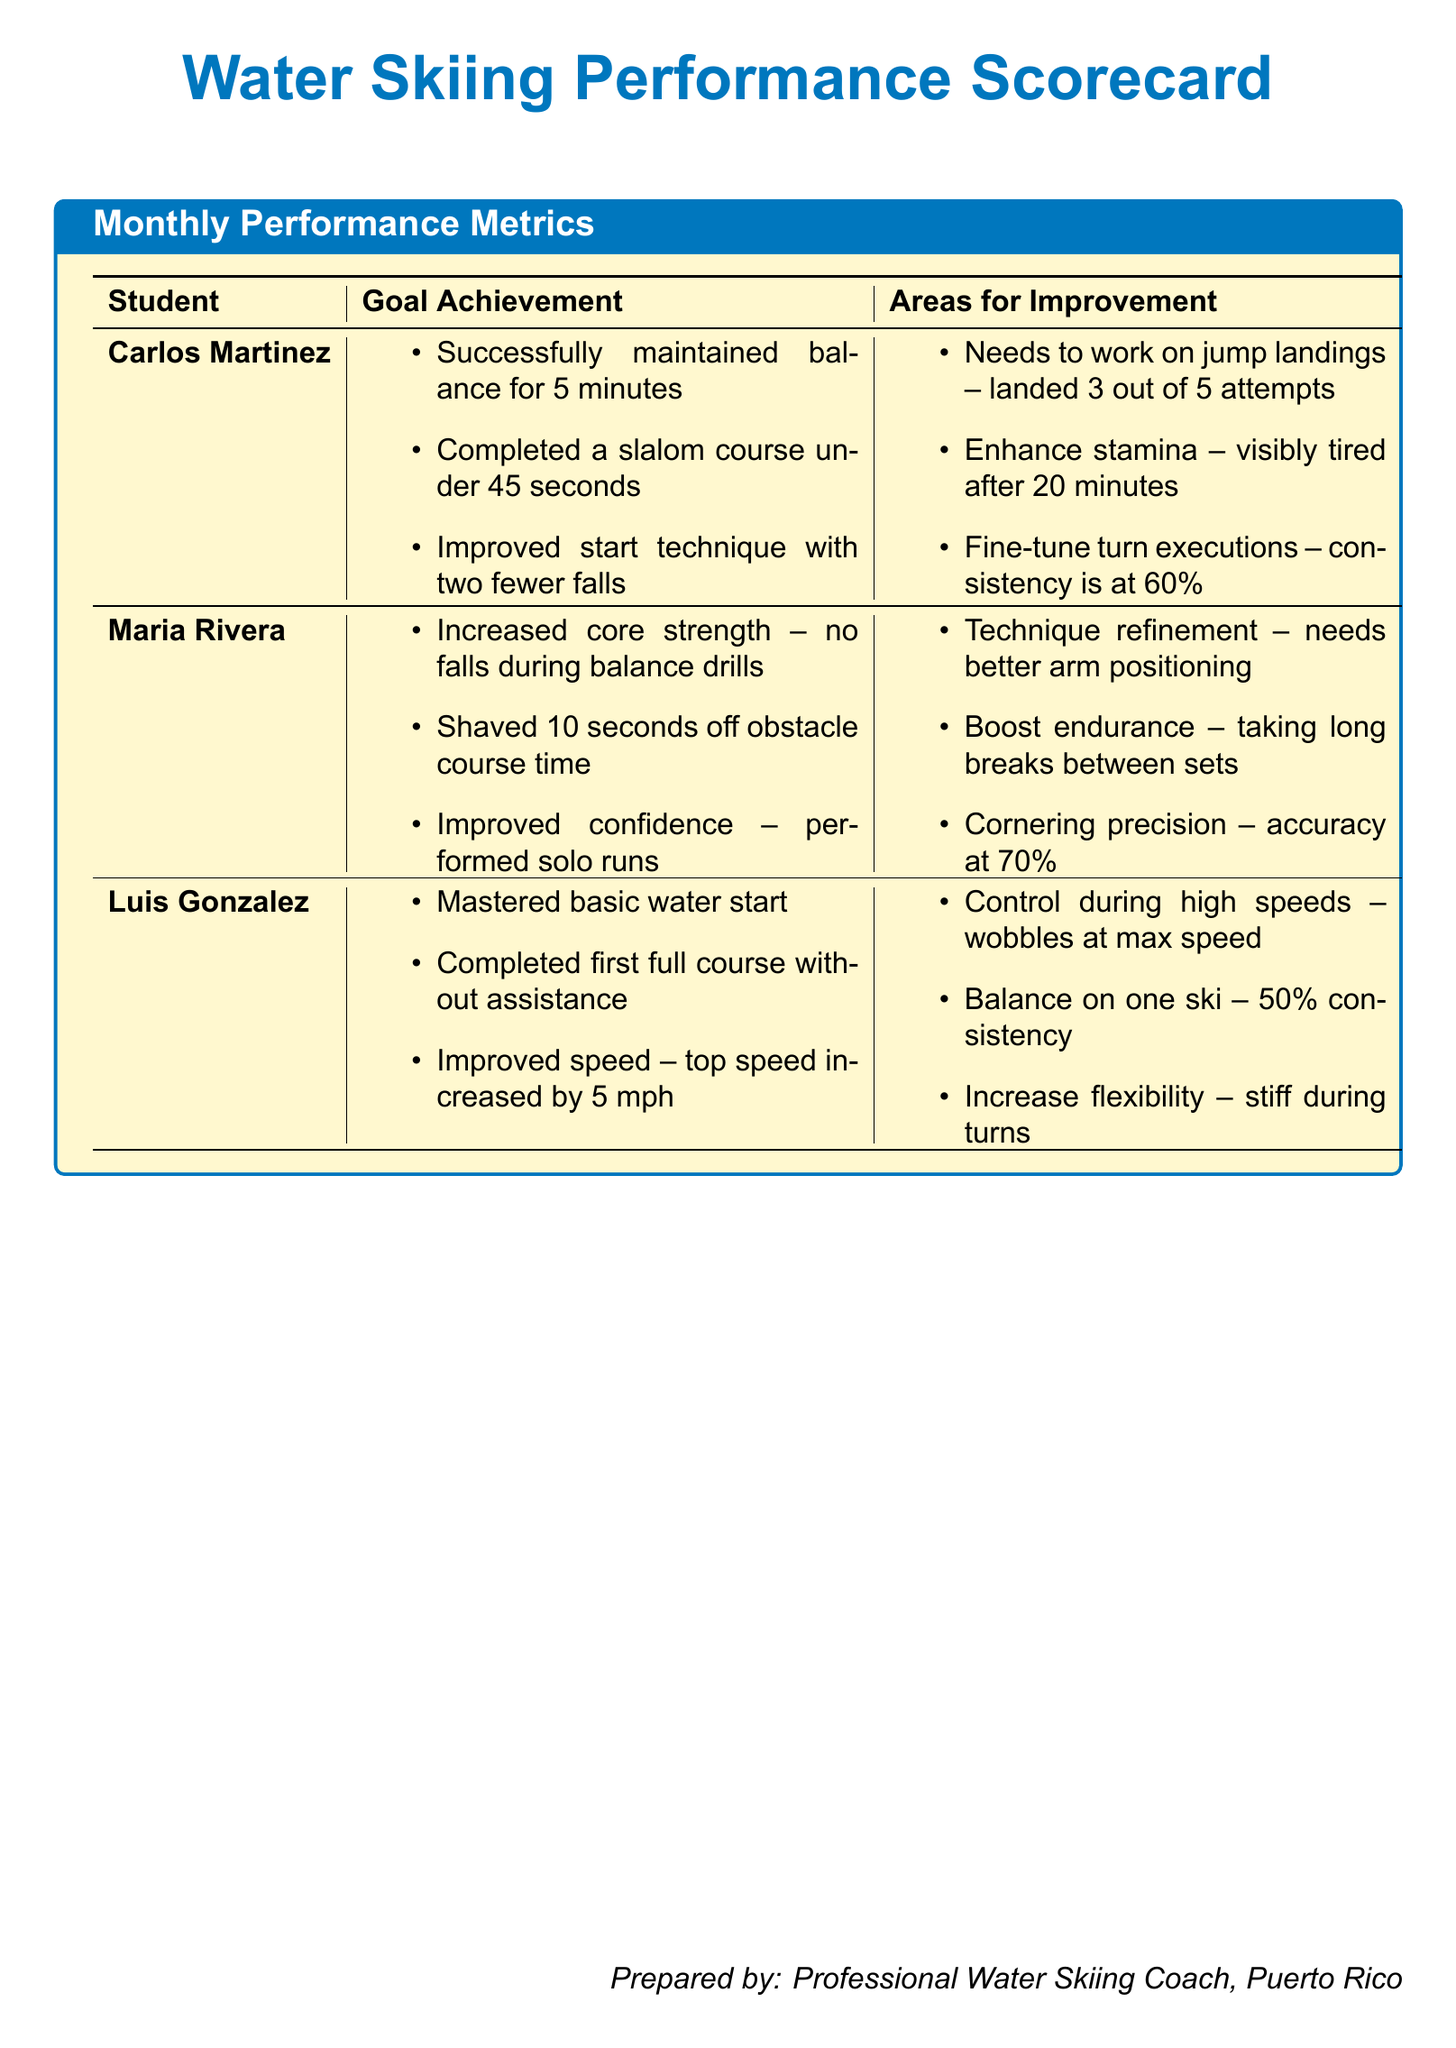What is the name of the first student listed? The first student in the scorecard is identified as Carlos Martinez.
Answer: Carlos Martinez How many successful jump landings did Carlos achieve? Carlos landed successfully on 3 out of 5 jump attempts.
Answer: 3 What is Maria's improvement in obstacle course time? Maria shaved off 10 seconds from her previous obstacle course time.
Answer: 10 seconds What is Luis' top speed increase? Luis's top speed increased by 5 mph, indicating progress in his performance.
Answer: 5 mph What area does Maria need to work on regarding her technique? Maria needs to work on her arm positioning to refine her skiing technique.
Answer: Arm positioning What is the consistency percentage for Luis while balancing on one ski? Luis has a 50% consistency when attempting to balance on one ski.
Answer: 50% Which student improved their confidence by performing solo runs? The student who improved their confidence and performed solo runs is Maria Rivera.
Answer: Maria Rivera What is the accuracy percentage for Maria's cornering precision? Maria's cornering precision accuracy is currently at 70%.
Answer: 70% 